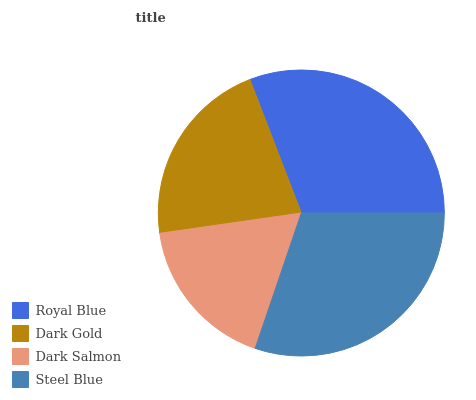Is Dark Salmon the minimum?
Answer yes or no. Yes. Is Royal Blue the maximum?
Answer yes or no. Yes. Is Dark Gold the minimum?
Answer yes or no. No. Is Dark Gold the maximum?
Answer yes or no. No. Is Royal Blue greater than Dark Gold?
Answer yes or no. Yes. Is Dark Gold less than Royal Blue?
Answer yes or no. Yes. Is Dark Gold greater than Royal Blue?
Answer yes or no. No. Is Royal Blue less than Dark Gold?
Answer yes or no. No. Is Steel Blue the high median?
Answer yes or no. Yes. Is Dark Gold the low median?
Answer yes or no. Yes. Is Dark Gold the high median?
Answer yes or no. No. Is Steel Blue the low median?
Answer yes or no. No. 